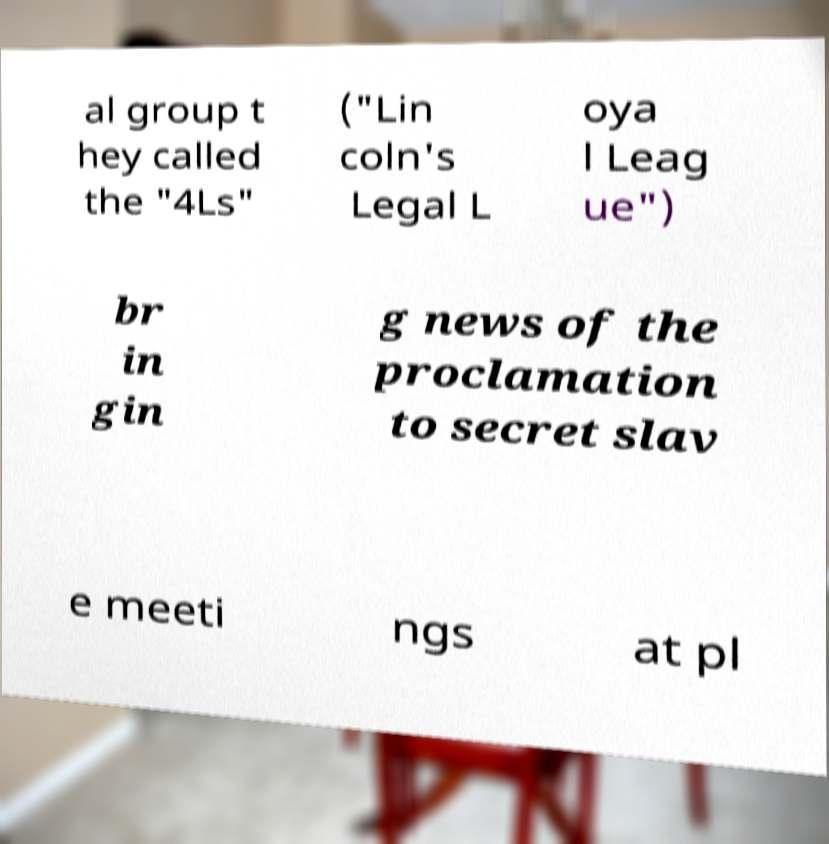Can you accurately transcribe the text from the provided image for me? al group t hey called the "4Ls" ("Lin coln's Legal L oya l Leag ue") br in gin g news of the proclamation to secret slav e meeti ngs at pl 